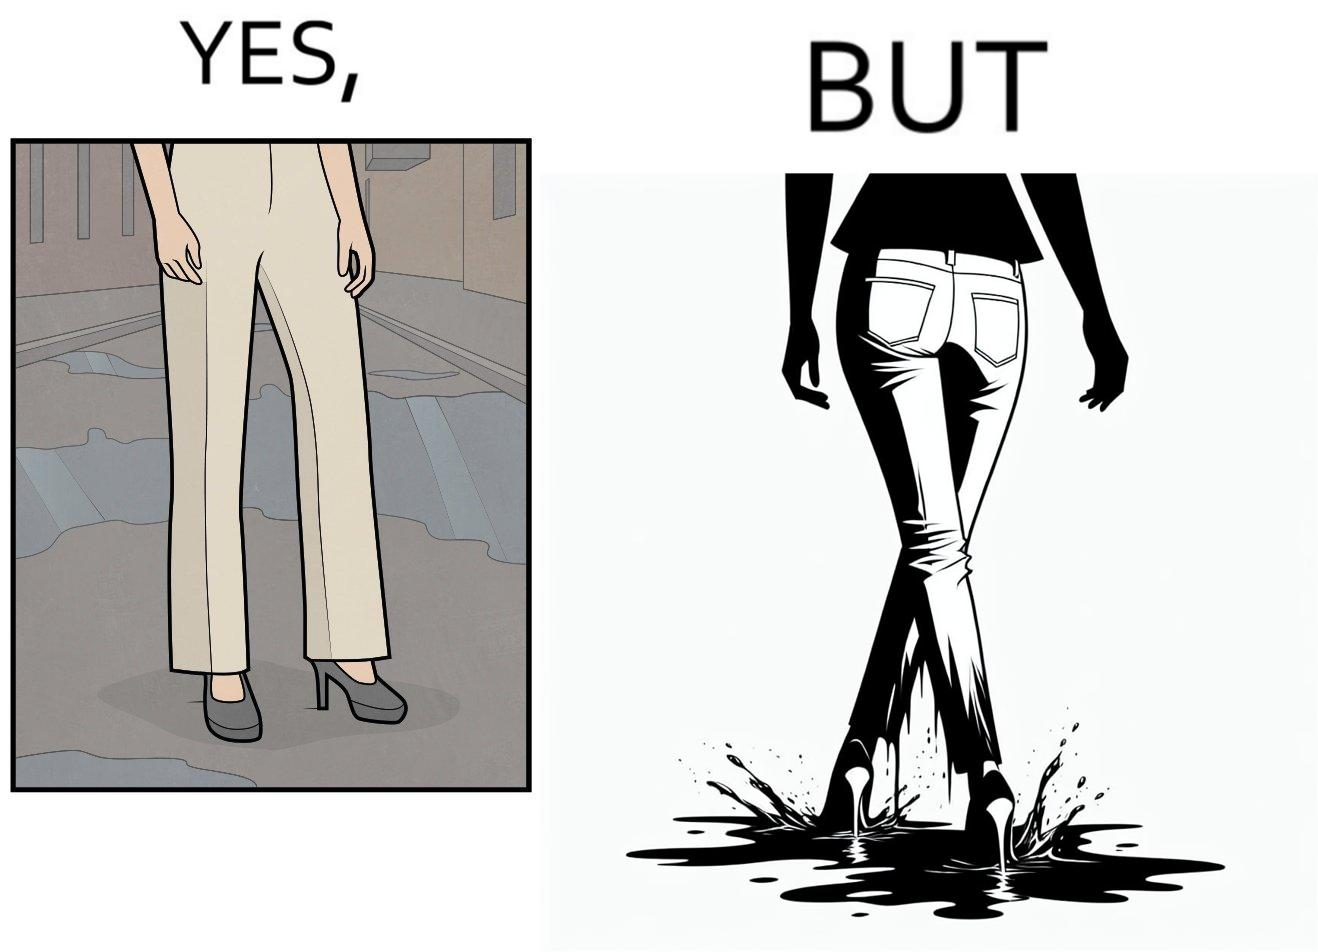What does this image depict? The image is funny, as when looking from the front, girl's pants are spick and span, while looking from the back, her pants are soaked in water, probably due to walking on a road filled with water in high heels. This is ironical, as the very reason for wearing heels (i.e. looking beautiful) is defeated, due to the heels themselves. 